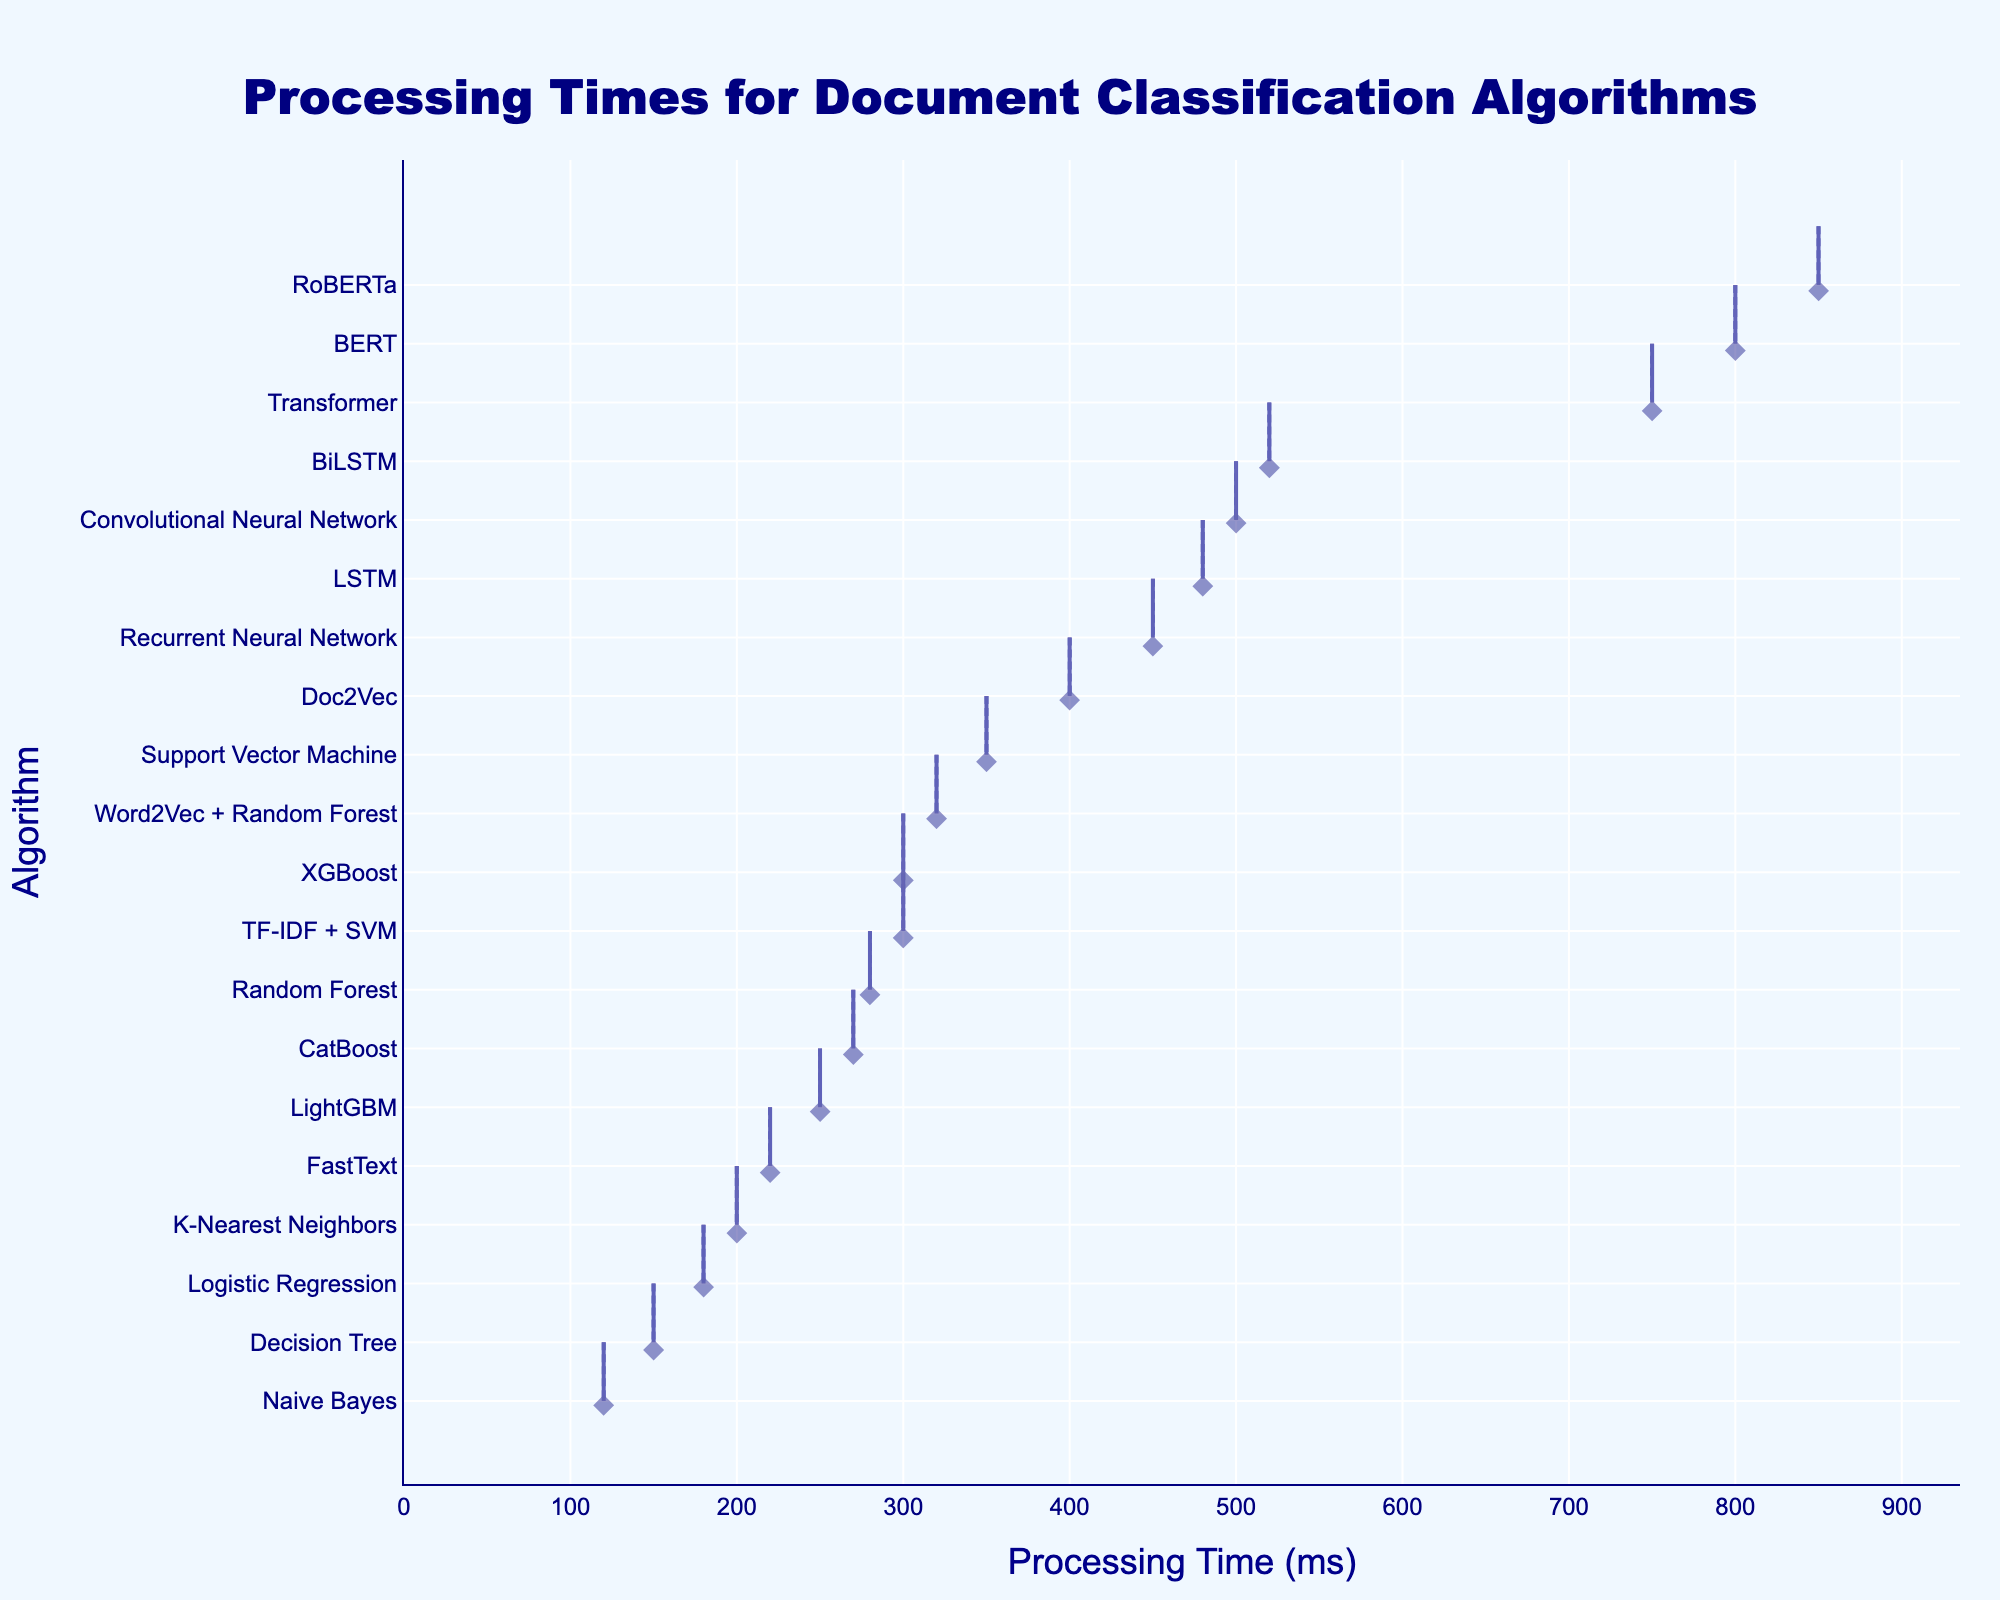What is the title of the figure? The title is displayed at the top of the figure and reads "Processing Times for Document Classification Algorithms".
Answer: "Processing Times for Document Classification Algorithms" What time range is covered on the x-axis? The figure shows that the x-axis starts at 0 and appears to end slightly beyond the highest value which is approximately 880ms, considering a 1.1 multiplier on the highest processing_time_ms.
Answer: 0 to around 880ms Which algorithm shows the longest processing time? The algorithm with the longest processing time will be the one at the top of the y-axis, having the highest value. In this case, it's RoBERTa with 850ms.
Answer: RoBERTa What are the 2nd and 3rd fastest algorithms? Sorting the algorithms by their processing time from the bottom upward, the 2nd and 3rd fastest algorithms are Decision Tree (150ms) and Logistic Regression (180ms).
Answer: Decision Tree and Logistic Regression How many algorithms have a processing time longer than 500ms? Reviewing the plot, the algorithms positioned higher than the 500ms mark on the x-axis are RoBERTa, Transformer, BiLSTM, LSTM, BERT, Recurrent Neural Network, and Convolutional Neural Network—totaling 7 algorithms.
Answer: 7 What is the difference in processing time between the slowest and fastest algorithms? The slowest algorithm is RoBERTa (850ms) and the fastest is Naive Bayes (120ms). The difference is calculated as 850ms - 120ms = 730ms.
Answer: 730ms Which algorithm has a processing time closest to the median processing time? Listing all processing times: 120, 150, 180, 200, 220, 250, 270, 280, 300, 300, 320, 350, 400, 450, 480, 500, 520, 750, 800, 850, the median is the average of the 10th (300ms) and 11th (300ms) values. The closest algorithm is XGBoost with 300ms.
Answer: XGBoost How many algorithms have "Neural Network" in their name and what are their processing times? The algorithms with "Neural Network" in their names are Convolutional Neural Network (500ms) and Recurrent Neural Network (450ms).
Answer: 2 (500ms and 450ms) What is the processing time range for algorithms between 100ms and 500ms? The algorithms in this range are Naive Bayes, Decision Tree, Logistic Regression, K-Nearest Neighbors, FastText, LightGBM, CatBoost, Random Forest, TF-IDF + SVM, XGBoost, and Word2Vec + Random Forest, with times ranging from 120ms to 320ms.
Answer: 120ms to 320ms 